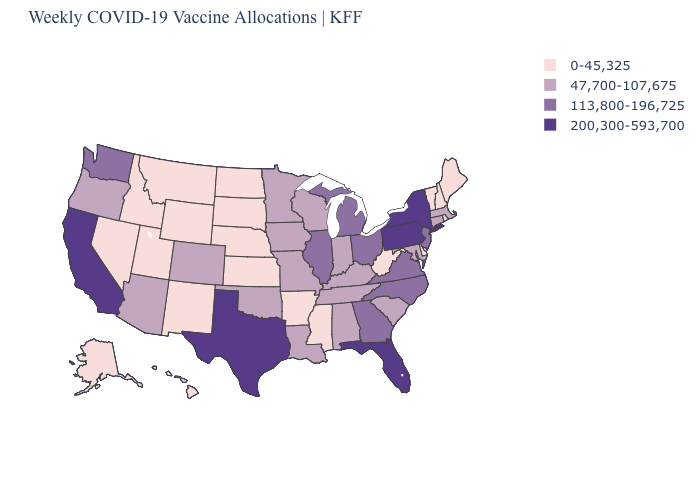What is the highest value in states that border North Dakota?
Be succinct. 47,700-107,675. Which states have the lowest value in the USA?
Quick response, please. Alaska, Arkansas, Delaware, Hawaii, Idaho, Kansas, Maine, Mississippi, Montana, Nebraska, Nevada, New Hampshire, New Mexico, North Dakota, Rhode Island, South Dakota, Utah, Vermont, West Virginia, Wyoming. What is the value of North Carolina?
Concise answer only. 113,800-196,725. Name the states that have a value in the range 47,700-107,675?
Keep it brief. Alabama, Arizona, Colorado, Connecticut, Indiana, Iowa, Kentucky, Louisiana, Maryland, Massachusetts, Minnesota, Missouri, Oklahoma, Oregon, South Carolina, Tennessee, Wisconsin. How many symbols are there in the legend?
Concise answer only. 4. Does Kansas have the same value as Ohio?
Quick response, please. No. Which states have the highest value in the USA?
Write a very short answer. California, Florida, New York, Pennsylvania, Texas. What is the highest value in states that border Washington?
Concise answer only. 47,700-107,675. Does Nebraska have the lowest value in the MidWest?
Answer briefly. Yes. What is the lowest value in the USA?
Short answer required. 0-45,325. What is the value of Oregon?
Concise answer only. 47,700-107,675. Does Iowa have the lowest value in the MidWest?
Be succinct. No. What is the value of Kansas?
Give a very brief answer. 0-45,325. What is the value of Iowa?
Answer briefly. 47,700-107,675. Does Massachusetts have the lowest value in the Northeast?
Give a very brief answer. No. 